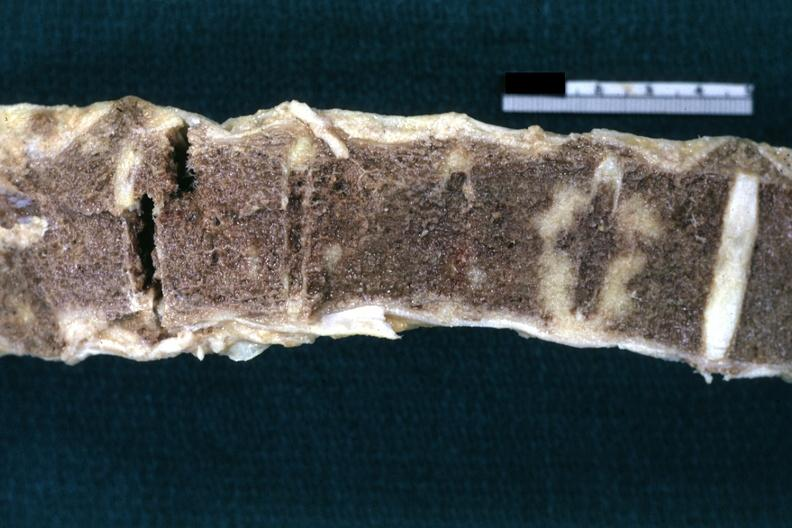what is present?
Answer the question using a single word or phrase. Joints 